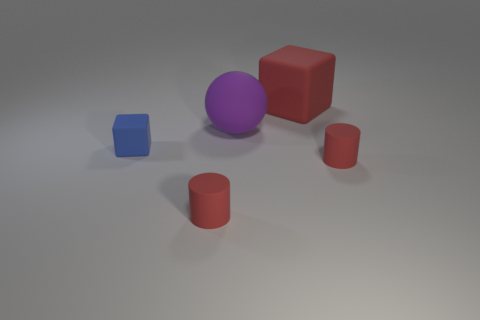Add 5 matte spheres. How many objects exist? 10 Subtract all cylinders. How many objects are left? 3 Add 4 tiny rubber cylinders. How many tiny rubber cylinders exist? 6 Subtract 1 blue blocks. How many objects are left? 4 Subtract all blue matte things. Subtract all cylinders. How many objects are left? 2 Add 3 large rubber balls. How many large rubber balls are left? 4 